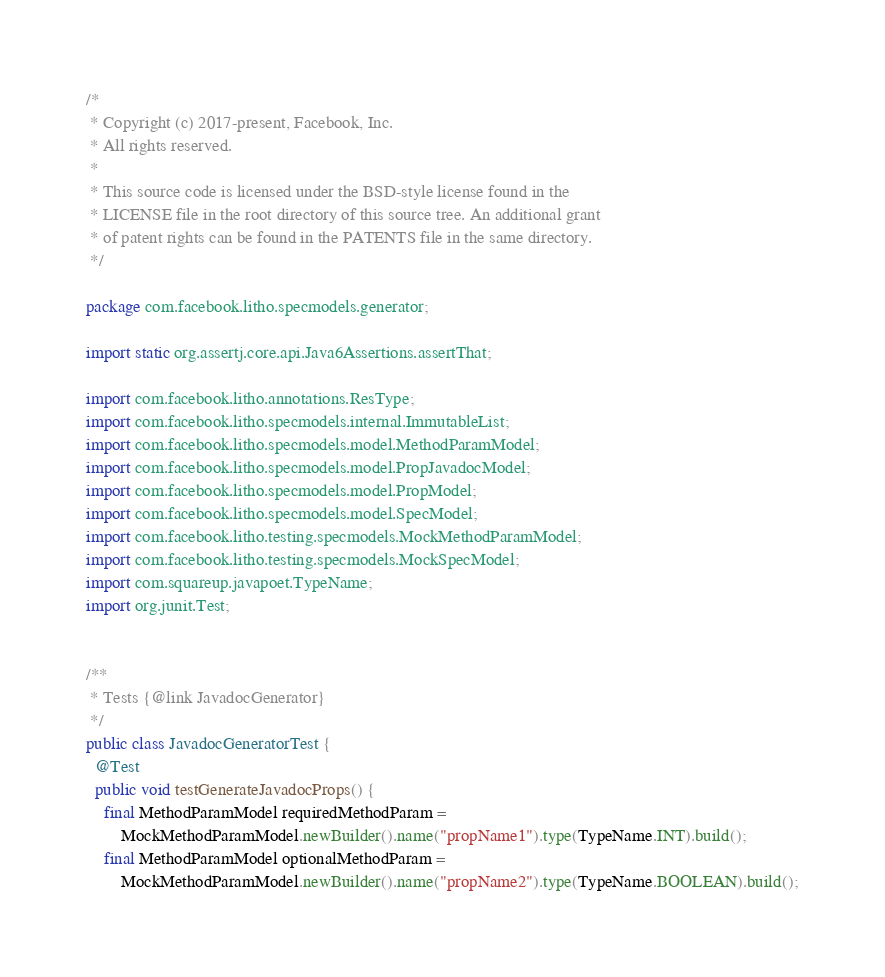Convert code to text. <code><loc_0><loc_0><loc_500><loc_500><_Java_>/*
 * Copyright (c) 2017-present, Facebook, Inc.
 * All rights reserved.
 *
 * This source code is licensed under the BSD-style license found in the
 * LICENSE file in the root directory of this source tree. An additional grant
 * of patent rights can be found in the PATENTS file in the same directory.
 */

package com.facebook.litho.specmodels.generator;

import static org.assertj.core.api.Java6Assertions.assertThat;

import com.facebook.litho.annotations.ResType;
import com.facebook.litho.specmodels.internal.ImmutableList;
import com.facebook.litho.specmodels.model.MethodParamModel;
import com.facebook.litho.specmodels.model.PropJavadocModel;
import com.facebook.litho.specmodels.model.PropModel;
import com.facebook.litho.specmodels.model.SpecModel;
import com.facebook.litho.testing.specmodels.MockMethodParamModel;
import com.facebook.litho.testing.specmodels.MockSpecModel;
import com.squareup.javapoet.TypeName;
import org.junit.Test;


/**
 * Tests {@link JavadocGenerator}
 */
public class JavadocGeneratorTest {
  @Test
  public void testGenerateJavadocProps() {
    final MethodParamModel requiredMethodParam =
        MockMethodParamModel.newBuilder().name("propName1").type(TypeName.INT).build();
    final MethodParamModel optionalMethodParam =
        MockMethodParamModel.newBuilder().name("propName2").type(TypeName.BOOLEAN).build();</code> 